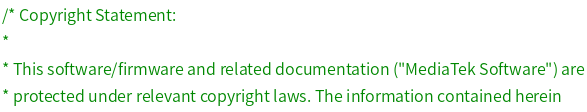Convert code to text. <code><loc_0><loc_0><loc_500><loc_500><_C_>/* Copyright Statement:
*
* This software/firmware and related documentation ("MediaTek Software") are
* protected under relevant copyright laws. The information contained herein</code> 